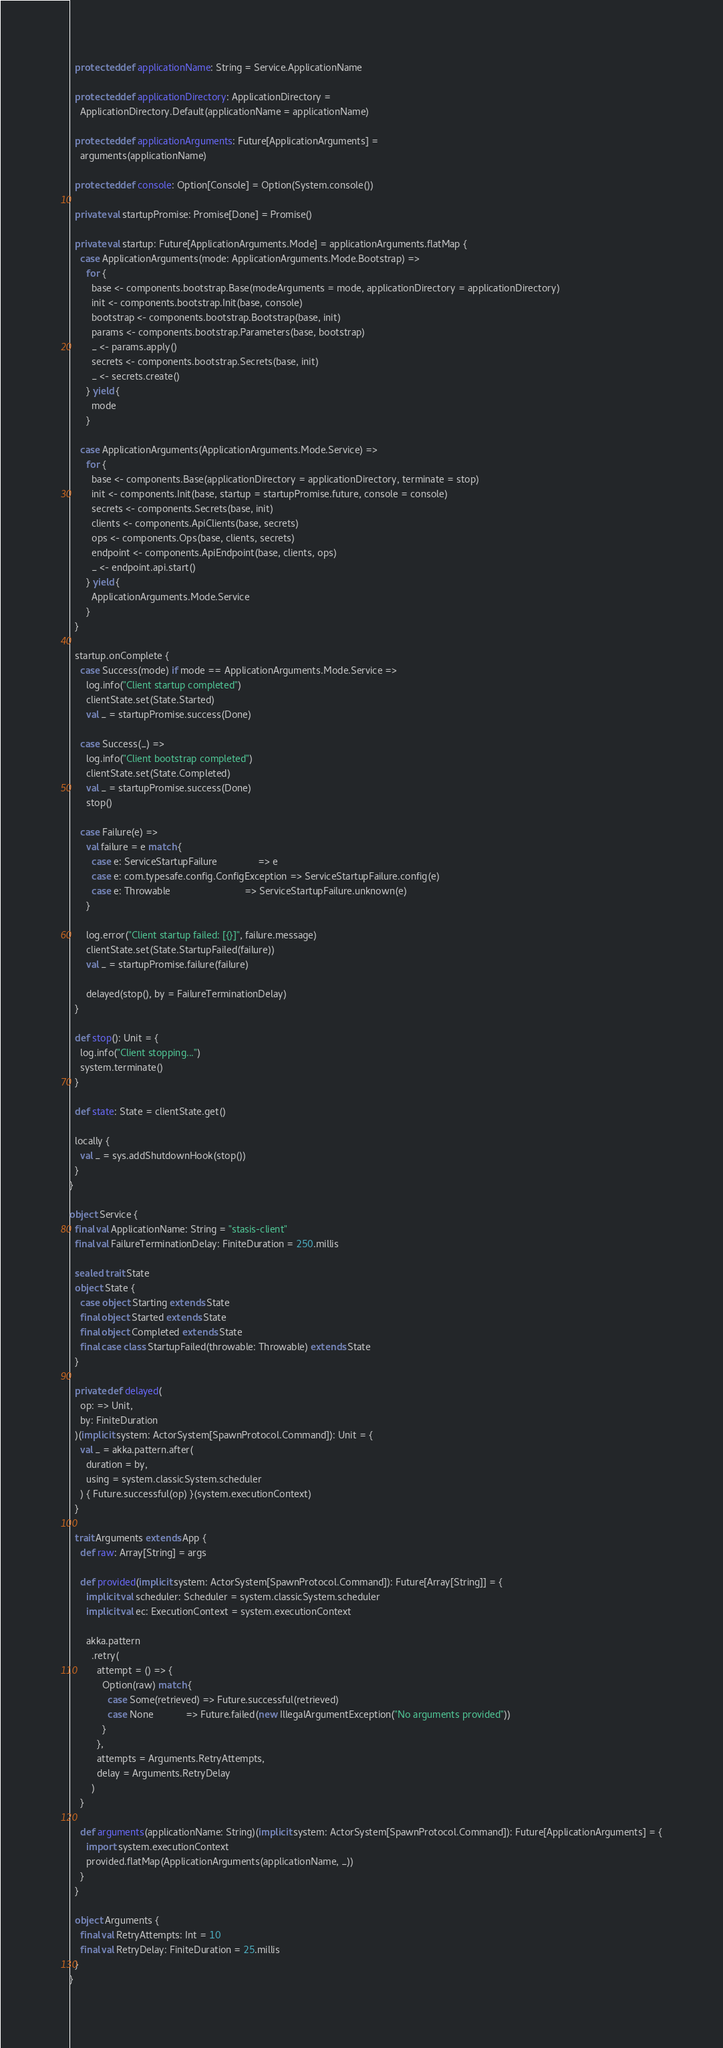Convert code to text. <code><loc_0><loc_0><loc_500><loc_500><_Scala_>
  protected def applicationName: String = Service.ApplicationName

  protected def applicationDirectory: ApplicationDirectory =
    ApplicationDirectory.Default(applicationName = applicationName)

  protected def applicationArguments: Future[ApplicationArguments] =
    arguments(applicationName)

  protected def console: Option[Console] = Option(System.console())

  private val startupPromise: Promise[Done] = Promise()

  private val startup: Future[ApplicationArguments.Mode] = applicationArguments.flatMap {
    case ApplicationArguments(mode: ApplicationArguments.Mode.Bootstrap) =>
      for {
        base <- components.bootstrap.Base(modeArguments = mode, applicationDirectory = applicationDirectory)
        init <- components.bootstrap.Init(base, console)
        bootstrap <- components.bootstrap.Bootstrap(base, init)
        params <- components.bootstrap.Parameters(base, bootstrap)
        _ <- params.apply()
        secrets <- components.bootstrap.Secrets(base, init)
        _ <- secrets.create()
      } yield {
        mode
      }

    case ApplicationArguments(ApplicationArguments.Mode.Service) =>
      for {
        base <- components.Base(applicationDirectory = applicationDirectory, terminate = stop)
        init <- components.Init(base, startup = startupPromise.future, console = console)
        secrets <- components.Secrets(base, init)
        clients <- components.ApiClients(base, secrets)
        ops <- components.Ops(base, clients, secrets)
        endpoint <- components.ApiEndpoint(base, clients, ops)
        _ <- endpoint.api.start()
      } yield {
        ApplicationArguments.Mode.Service
      }
  }

  startup.onComplete {
    case Success(mode) if mode == ApplicationArguments.Mode.Service =>
      log.info("Client startup completed")
      clientState.set(State.Started)
      val _ = startupPromise.success(Done)

    case Success(_) =>
      log.info("Client bootstrap completed")
      clientState.set(State.Completed)
      val _ = startupPromise.success(Done)
      stop()

    case Failure(e) =>
      val failure = e match {
        case e: ServiceStartupFailure               => e
        case e: com.typesafe.config.ConfigException => ServiceStartupFailure.config(e)
        case e: Throwable                           => ServiceStartupFailure.unknown(e)
      }

      log.error("Client startup failed: [{}]", failure.message)
      clientState.set(State.StartupFailed(failure))
      val _ = startupPromise.failure(failure)

      delayed(stop(), by = FailureTerminationDelay)
  }

  def stop(): Unit = {
    log.info("Client stopping...")
    system.terminate()
  }

  def state: State = clientState.get()

  locally {
    val _ = sys.addShutdownHook(stop())
  }
}

object Service {
  final val ApplicationName: String = "stasis-client"
  final val FailureTerminationDelay: FiniteDuration = 250.millis

  sealed trait State
  object State {
    case object Starting extends State
    final object Started extends State
    final object Completed extends State
    final case class StartupFailed(throwable: Throwable) extends State
  }

  private def delayed(
    op: => Unit,
    by: FiniteDuration
  )(implicit system: ActorSystem[SpawnProtocol.Command]): Unit = {
    val _ = akka.pattern.after(
      duration = by,
      using = system.classicSystem.scheduler
    ) { Future.successful(op) }(system.executionContext)
  }

  trait Arguments extends App {
    def raw: Array[String] = args

    def provided(implicit system: ActorSystem[SpawnProtocol.Command]): Future[Array[String]] = {
      implicit val scheduler: Scheduler = system.classicSystem.scheduler
      implicit val ec: ExecutionContext = system.executionContext

      akka.pattern
        .retry(
          attempt = () => {
            Option(raw) match {
              case Some(retrieved) => Future.successful(retrieved)
              case None            => Future.failed(new IllegalArgumentException("No arguments provided"))
            }
          },
          attempts = Arguments.RetryAttempts,
          delay = Arguments.RetryDelay
        )
    }

    def arguments(applicationName: String)(implicit system: ActorSystem[SpawnProtocol.Command]): Future[ApplicationArguments] = {
      import system.executionContext
      provided.flatMap(ApplicationArguments(applicationName, _))
    }
  }

  object Arguments {
    final val RetryAttempts: Int = 10
    final val RetryDelay: FiniteDuration = 25.millis
  }
}
</code> 